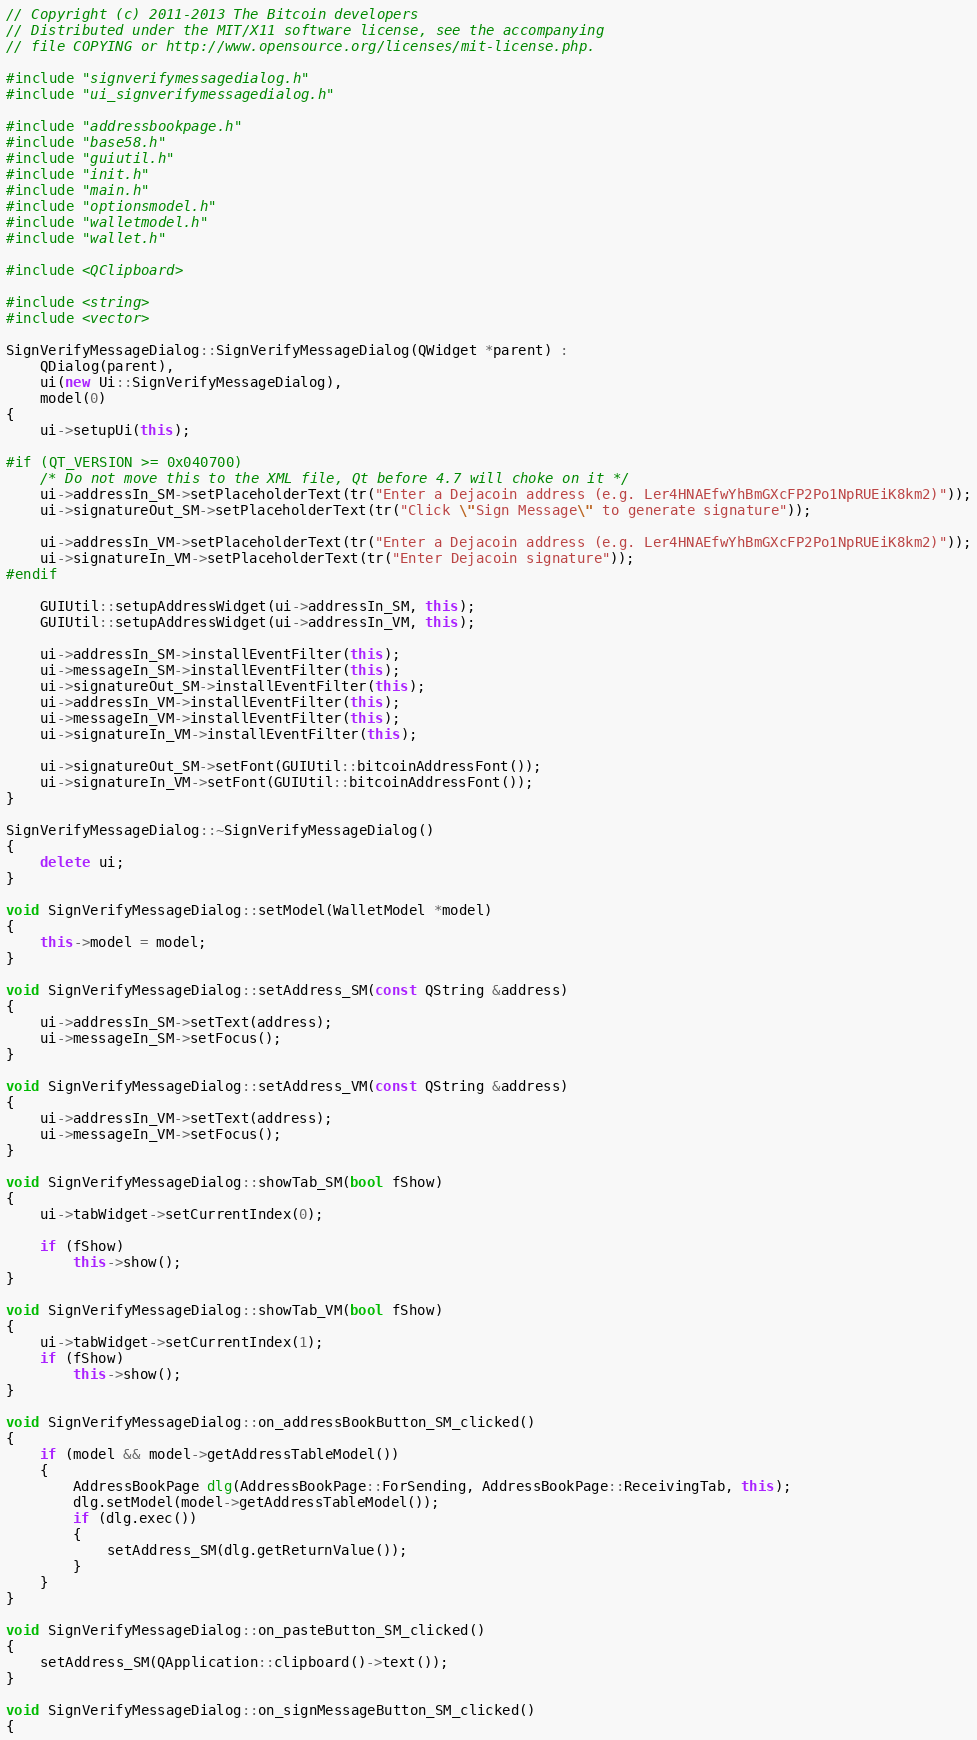<code> <loc_0><loc_0><loc_500><loc_500><_C++_>// Copyright (c) 2011-2013 The Bitcoin developers
// Distributed under the MIT/X11 software license, see the accompanying
// file COPYING or http://www.opensource.org/licenses/mit-license.php.

#include "signverifymessagedialog.h"
#include "ui_signverifymessagedialog.h"

#include "addressbookpage.h"
#include "base58.h"
#include "guiutil.h"
#include "init.h"
#include "main.h"
#include "optionsmodel.h"
#include "walletmodel.h"
#include "wallet.h"

#include <QClipboard>

#include <string>
#include <vector>

SignVerifyMessageDialog::SignVerifyMessageDialog(QWidget *parent) :
    QDialog(parent),
    ui(new Ui::SignVerifyMessageDialog),
    model(0)
{
    ui->setupUi(this);

#if (QT_VERSION >= 0x040700)
    /* Do not move this to the XML file, Qt before 4.7 will choke on it */
    ui->addressIn_SM->setPlaceholderText(tr("Enter a Dejacoin address (e.g. Ler4HNAEfwYhBmGXcFP2Po1NpRUEiK8km2)"));
    ui->signatureOut_SM->setPlaceholderText(tr("Click \"Sign Message\" to generate signature"));

    ui->addressIn_VM->setPlaceholderText(tr("Enter a Dejacoin address (e.g. Ler4HNAEfwYhBmGXcFP2Po1NpRUEiK8km2)"));
    ui->signatureIn_VM->setPlaceholderText(tr("Enter Dejacoin signature"));
#endif

    GUIUtil::setupAddressWidget(ui->addressIn_SM, this);
    GUIUtil::setupAddressWidget(ui->addressIn_VM, this);

    ui->addressIn_SM->installEventFilter(this);
    ui->messageIn_SM->installEventFilter(this);
    ui->signatureOut_SM->installEventFilter(this);
    ui->addressIn_VM->installEventFilter(this);
    ui->messageIn_VM->installEventFilter(this);
    ui->signatureIn_VM->installEventFilter(this);

    ui->signatureOut_SM->setFont(GUIUtil::bitcoinAddressFont());
    ui->signatureIn_VM->setFont(GUIUtil::bitcoinAddressFont());
}

SignVerifyMessageDialog::~SignVerifyMessageDialog()
{
    delete ui;
}

void SignVerifyMessageDialog::setModel(WalletModel *model)
{
    this->model = model;
}

void SignVerifyMessageDialog::setAddress_SM(const QString &address)
{
    ui->addressIn_SM->setText(address);
    ui->messageIn_SM->setFocus();
}

void SignVerifyMessageDialog::setAddress_VM(const QString &address)
{
    ui->addressIn_VM->setText(address);
    ui->messageIn_VM->setFocus();
}

void SignVerifyMessageDialog::showTab_SM(bool fShow)
{
    ui->tabWidget->setCurrentIndex(0);

    if (fShow)
        this->show();
}

void SignVerifyMessageDialog::showTab_VM(bool fShow)
{
    ui->tabWidget->setCurrentIndex(1);
    if (fShow)
        this->show();
}

void SignVerifyMessageDialog::on_addressBookButton_SM_clicked()
{
    if (model && model->getAddressTableModel())
    {
        AddressBookPage dlg(AddressBookPage::ForSending, AddressBookPage::ReceivingTab, this);
        dlg.setModel(model->getAddressTableModel());
        if (dlg.exec())
        {
            setAddress_SM(dlg.getReturnValue());
        }
    }
}

void SignVerifyMessageDialog::on_pasteButton_SM_clicked()
{
    setAddress_SM(QApplication::clipboard()->text());
}

void SignVerifyMessageDialog::on_signMessageButton_SM_clicked()
{</code> 